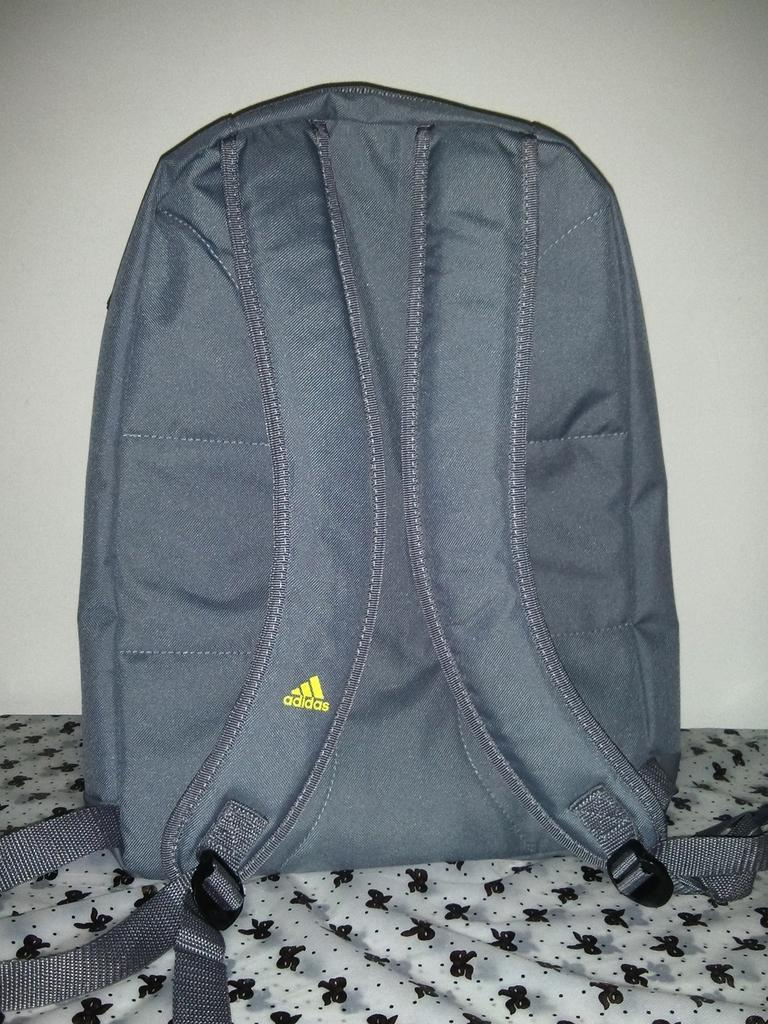Provide a one-sentence caption for the provided image. A grey adidas back pack on a white sheet with black bows on it. 